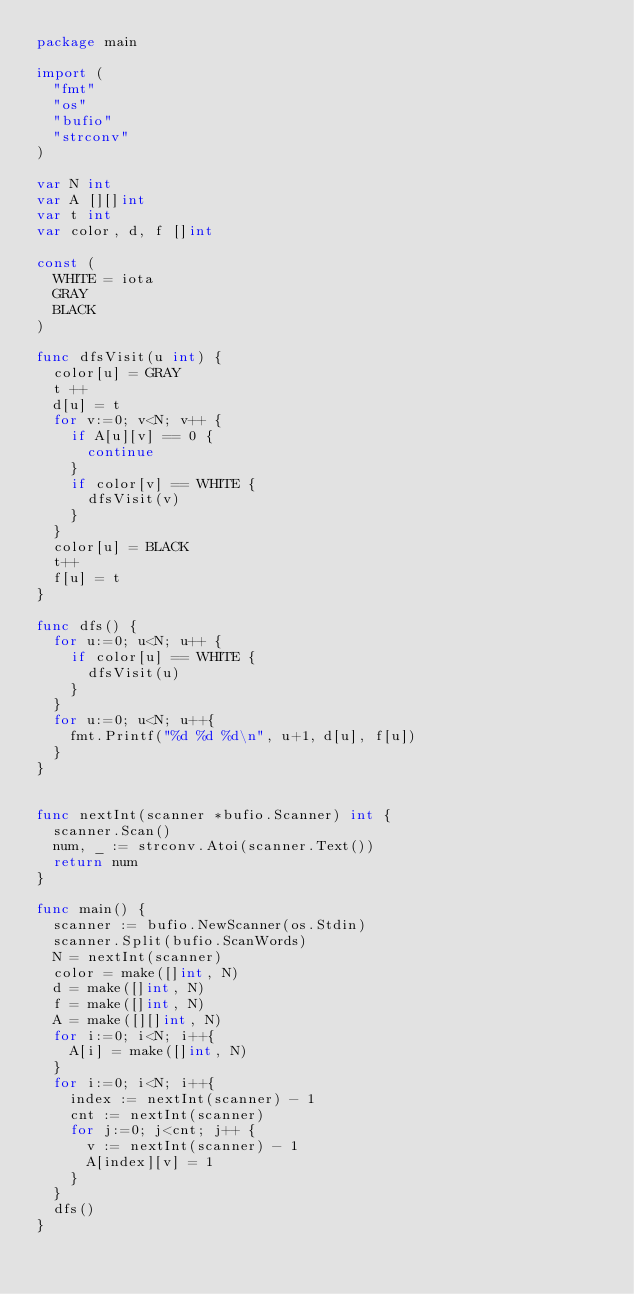<code> <loc_0><loc_0><loc_500><loc_500><_Go_>package main

import (
	"fmt"
	"os"
	"bufio"
	"strconv"
)

var N int
var A [][]int
var t int
var color, d, f []int

const (
	WHITE = iota
	GRAY
	BLACK
)

func dfsVisit(u int) {
	color[u] = GRAY
	t ++
	d[u] = t
	for v:=0; v<N; v++ {
		if A[u][v] == 0 {
			continue
		}
		if color[v] == WHITE {
			dfsVisit(v)
		}
	}
	color[u] = BLACK
	t++
	f[u] = t
}

func dfs() {
	for u:=0; u<N; u++ {
		if color[u] == WHITE {
			dfsVisit(u)
		}
	}
	for u:=0; u<N; u++{
		fmt.Printf("%d %d %d\n", u+1, d[u], f[u])
	}
}


func nextInt(scanner *bufio.Scanner) int {
	scanner.Scan()
	num, _ := strconv.Atoi(scanner.Text())
	return num
}

func main() {
	scanner := bufio.NewScanner(os.Stdin)
	scanner.Split(bufio.ScanWords)
	N = nextInt(scanner)
	color = make([]int, N)
	d = make([]int, N)
	f = make([]int, N)
	A = make([][]int, N)
	for i:=0; i<N; i++{
		A[i] = make([]int, N)
	}
	for i:=0; i<N; i++{
		index := nextInt(scanner) - 1
		cnt := nextInt(scanner)
		for j:=0; j<cnt; j++ {
			v := nextInt(scanner) - 1
			A[index][v] = 1
		}
	}
	dfs()
}



</code> 